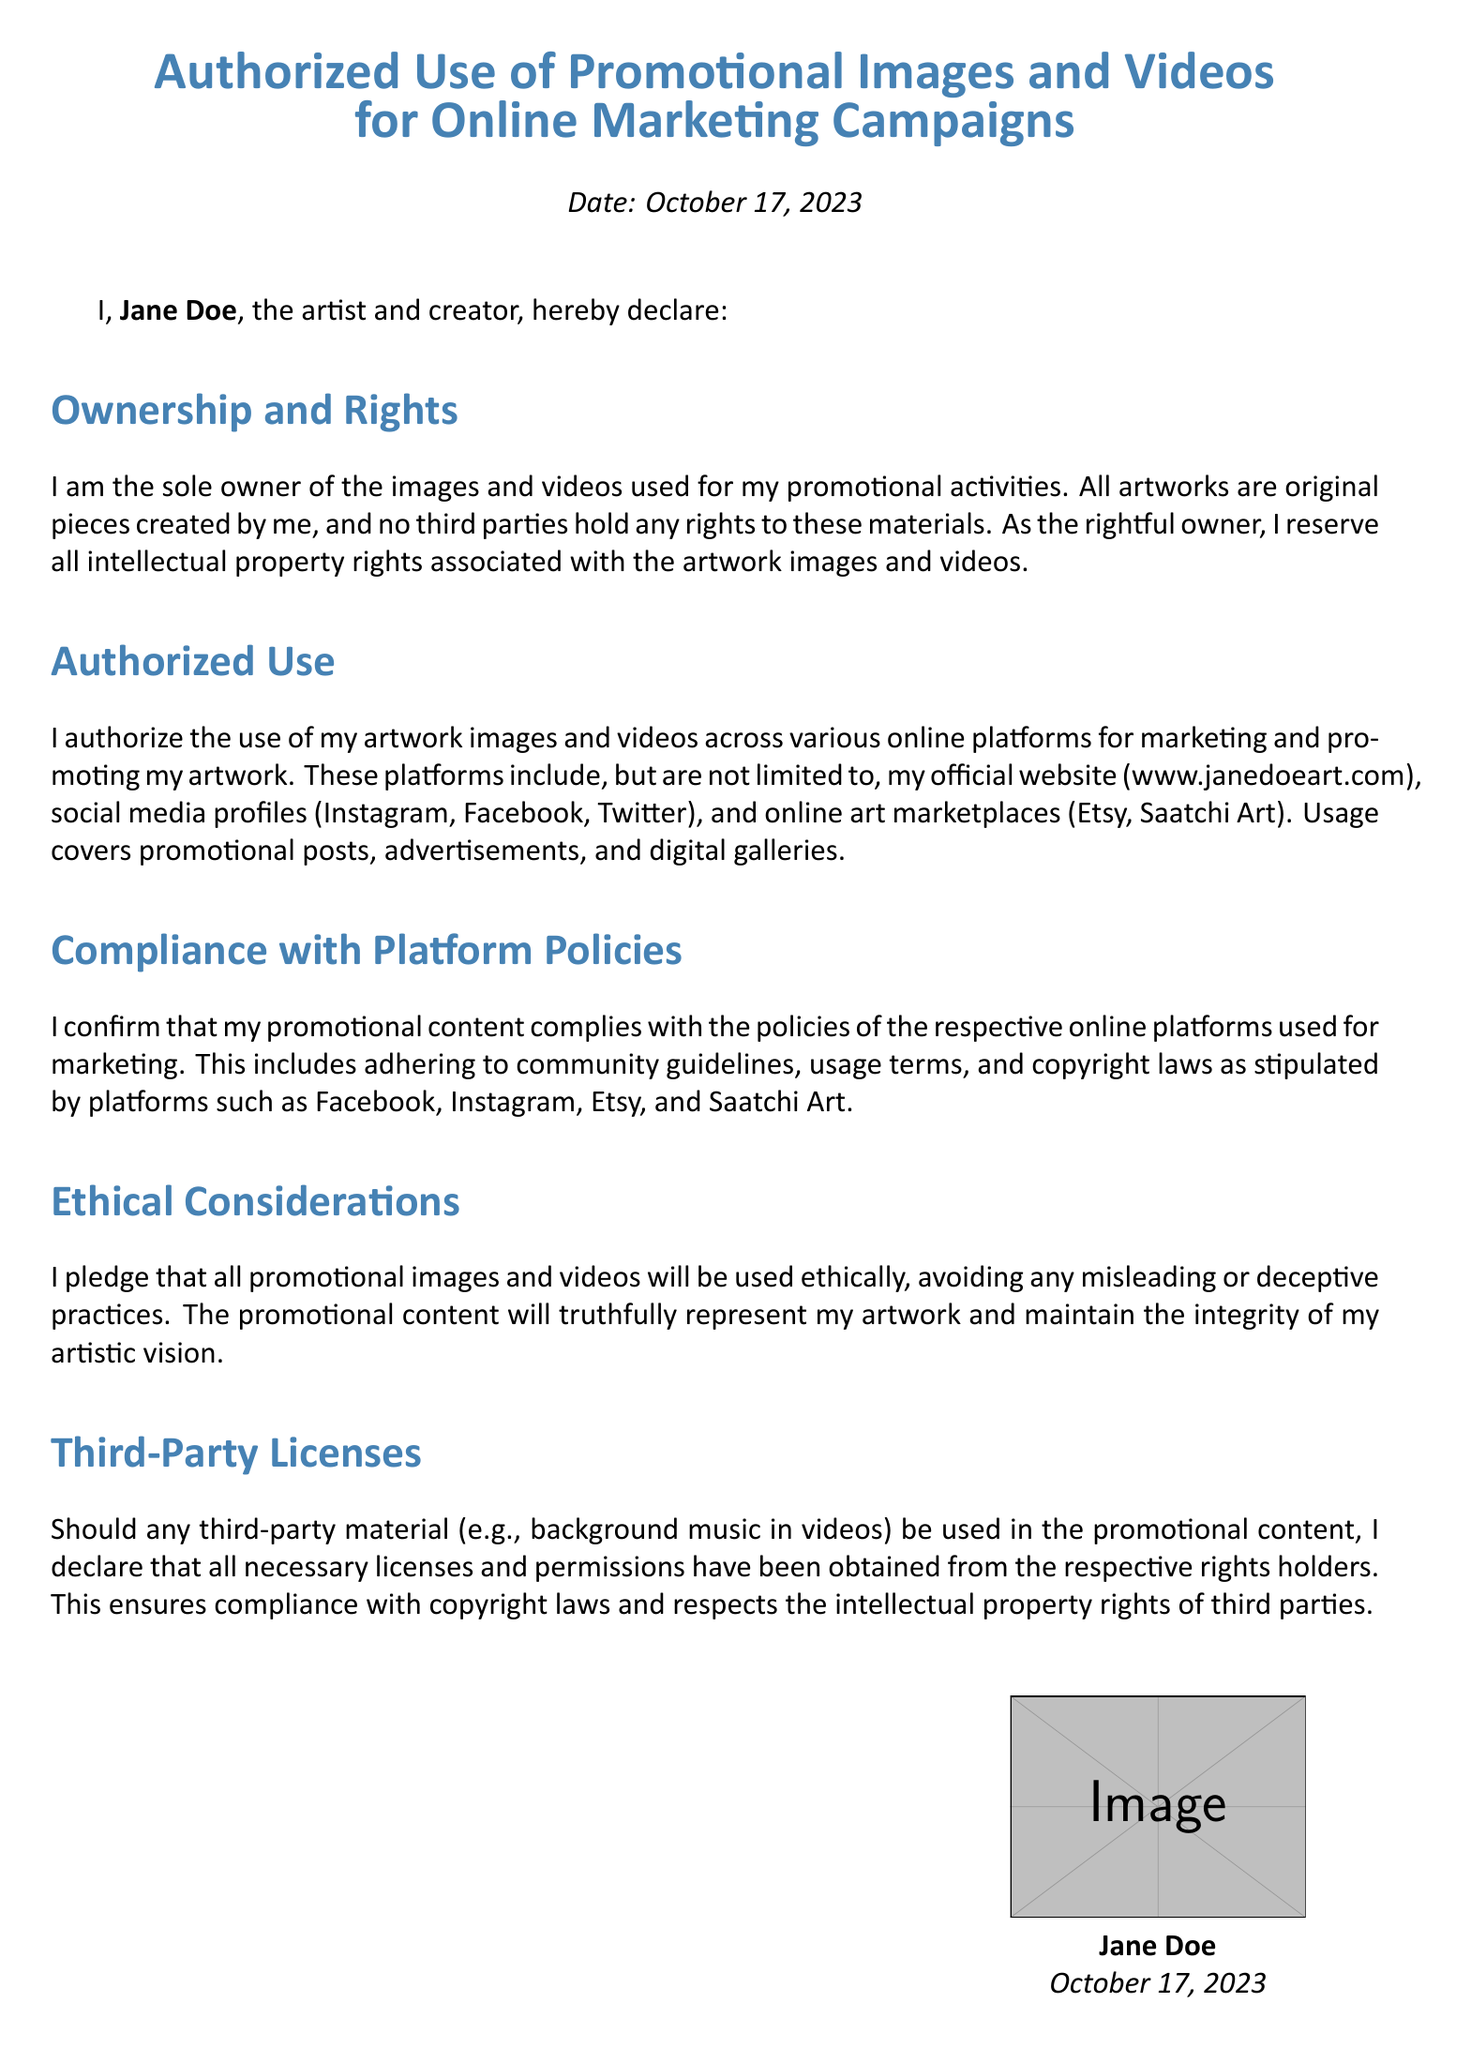What is the date of the declaration? The date of the declaration is stated at the top of the document.
Answer: October 17, 2023 Who is the artist making the declaration? The artist's name is mentioned in the declaration.
Answer: Jane Doe What platforms are authorized for the use of artwork images and videos? The declaration lists various online platforms for promotional purposes.
Answer: Instagram, Facebook, Twitter, Etsy, Saatchi Art What will the promotional content truthfully represent? The declaration specifies the integrity of what the promotional content should represent.
Answer: My artwork What is required when using third-party material in promotional content? The declaration outlines compliance concerning the use of third-party materials.
Answer: Necessary licenses and permissions What does the artist reserve regarding their artwork? The declaration mentions the ownership rights of the artwork explicitly.
Answer: All intellectual property rights How is the document structured? The declaration is organized into specific sections that outline different aspects of usage.
Answer: Sections What ethical pledge does the artist make regarding promotional images and videos? The declaration includes a commitment about the nature of how the promotional content will be used.
Answer: Used ethically 